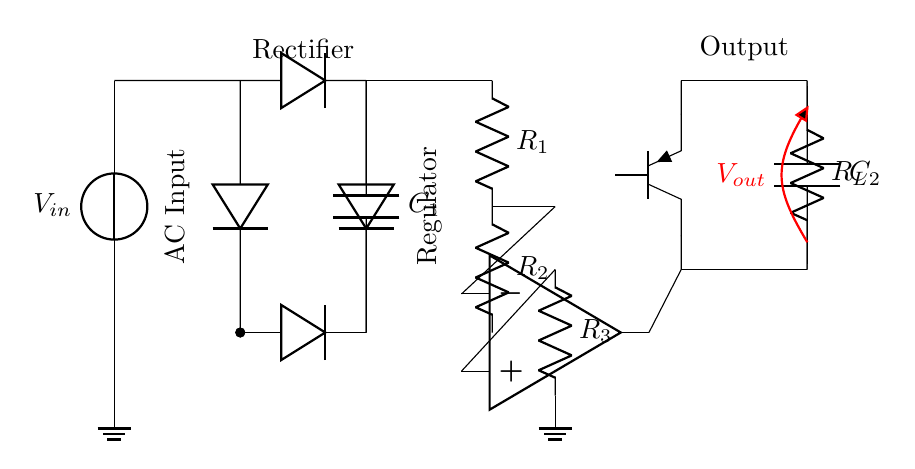What is the input voltage type in this circuit? The input voltage is AC as indicated by the source symbol and the labeling.
Answer: AC What components are used for voltage regulation? The components used for voltage regulation include resistors, an operational amplifier, and a transistor. These elements together help maintain a steady output voltage.
Answer: Resistors, operational amplifier, transistor What is the function of capacitor C1? Capacitor C1 smoothens the output of the rectifier by filtering the pulsating DC voltage, resulting in a more stable voltage output.
Answer: Smoothing How many resistors are there in the voltage regulator section? There are three resistors labeled R1, R2, and R3 present in the voltage regulator section.
Answer: Three How does the operational amplifier contribute to the circuit? The operational amplifier amplifies the difference between its input terminals, thereby controlling the output voltage by feedback mechanisms with the resistors.
Answer: Feedback control What is the purpose of the output capacitor C2? The purpose of capacitor C2 is to stabilize the output voltage by filtering any high-frequency noise, ensuring a clean DC output.
Answer: Stabilization 